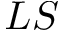<formula> <loc_0><loc_0><loc_500><loc_500>L S</formula> 